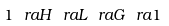<formula> <loc_0><loc_0><loc_500><loc_500>1 \ r a H \ r a L \ r a G \ r a 1</formula> 